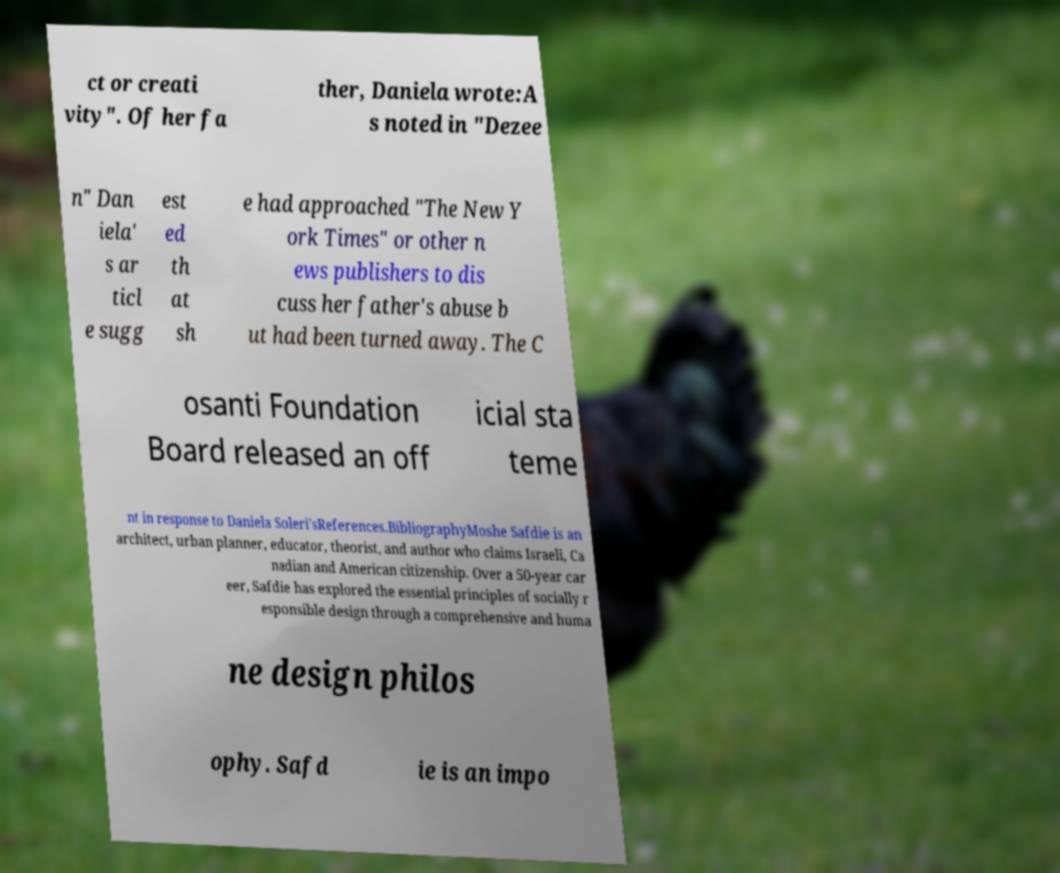What messages or text are displayed in this image? I need them in a readable, typed format. ct or creati vity". Of her fa ther, Daniela wrote:A s noted in "Dezee n" Dan iela' s ar ticl e sugg est ed th at sh e had approached "The New Y ork Times" or other n ews publishers to dis cuss her father's abuse b ut had been turned away. The C osanti Foundation Board released an off icial sta teme nt in response to Daniela Soleri'sReferences.BibliographyMoshe Safdie is an architect, urban planner, educator, theorist, and author who claims Israeli, Ca nadian and American citizenship. Over a 50-year car eer, Safdie has explored the essential principles of socially r esponsible design through a comprehensive and huma ne design philos ophy. Safd ie is an impo 